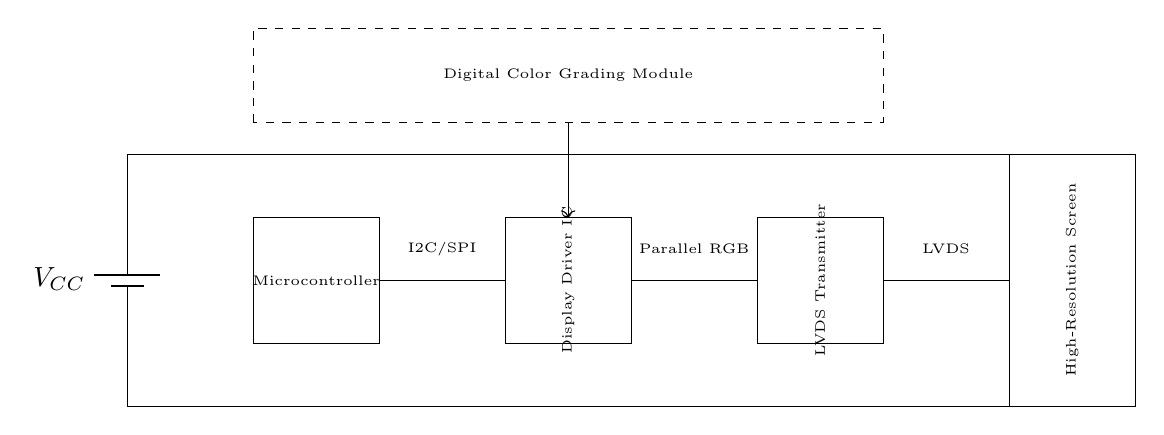What is the primary function of the Microcontroller? The primary function of the Microcontroller, as indicated in the circuit diagram, is to process control signals and interface with the digital color grading module using communication protocols like I2C or SPI.
Answer: Control signals What type of signal does the LVDS Transmitter output? The LVDS Transmitter is responsible for converting the data into Low-Voltage Differential Signaling (LVDS), which is a technique used to transmit data at high speeds over twisted pairs.
Answer: LVDS How many main components are shown in the circuit? By counting the various components indicated in the circuit diagram, we identify a total of four main components: a Microcontroller, a Display Driver IC, an LVDS Transmitter, and a High-Resolution Screen.
Answer: Four Which component receives signals from the Microcontroller? The component that receives signals from the Microcontroller is the Display Driver IC, as it is directly connected to it for processing the display control signals.
Answer: Display Driver IC What is the connection type between the Display Driver IC and the LVDS Transmitter? The connection type between the Display Driver IC and the LVDS Transmitter is a parallel RGB connection, indicated in the circuit as the communication interface between these two components.
Answer: Parallel RGB Identify the type of module connected to the Microcontroller. The module connected to the Microcontroller, as denoted in the circuit, is the Digital Color Grading Module, which helps in processing visual information in film production.
Answer: Digital Color Grading Module What voltage is noted at the power supply in the circuit? The circuit diagram indicates a battery with a potential marked as VCC at the upper voltage connection, which represents the power supply voltage for the entire device.
Answer: VCC 